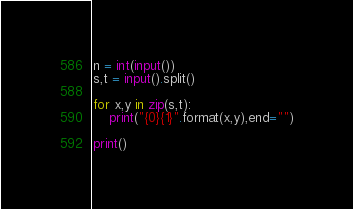<code> <loc_0><loc_0><loc_500><loc_500><_Python_>n = int(input())
s,t = input().split()

for x,y in zip(s,t):
    print("{0}{1}".format(x,y),end="")

print()</code> 